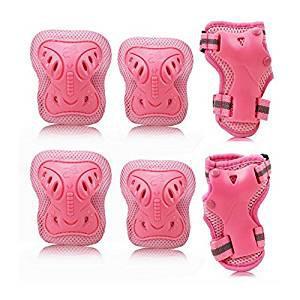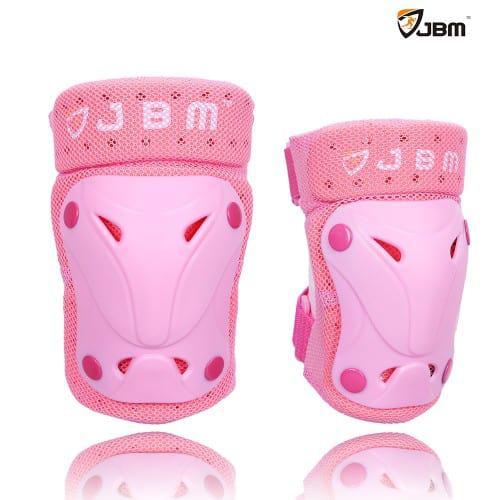The first image is the image on the left, the second image is the image on the right. For the images displayed, is the sentence "In at least one of the images, we see only knee pads; no elbow pads or gloves." factually correct? Answer yes or no. Yes. 